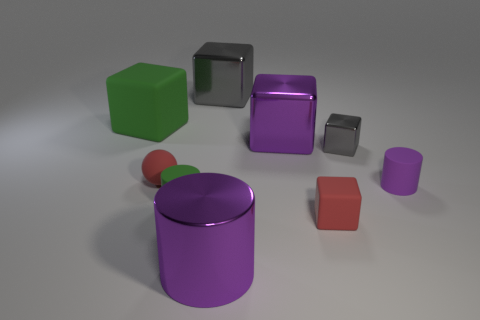Subtract all tiny metal blocks. How many blocks are left? 4 Subtract all red blocks. How many blocks are left? 4 Subtract all gray cylinders. How many gray blocks are left? 2 Subtract 1 spheres. How many spheres are left? 0 Subtract all cylinders. How many objects are left? 6 Subtract all green balls. Subtract all purple cubes. How many balls are left? 1 Subtract all red blocks. Subtract all tiny gray metal things. How many objects are left? 7 Add 8 tiny gray metal things. How many tiny gray metal things are left? 9 Add 8 yellow matte cylinders. How many yellow matte cylinders exist? 8 Subtract 0 cyan balls. How many objects are left? 9 